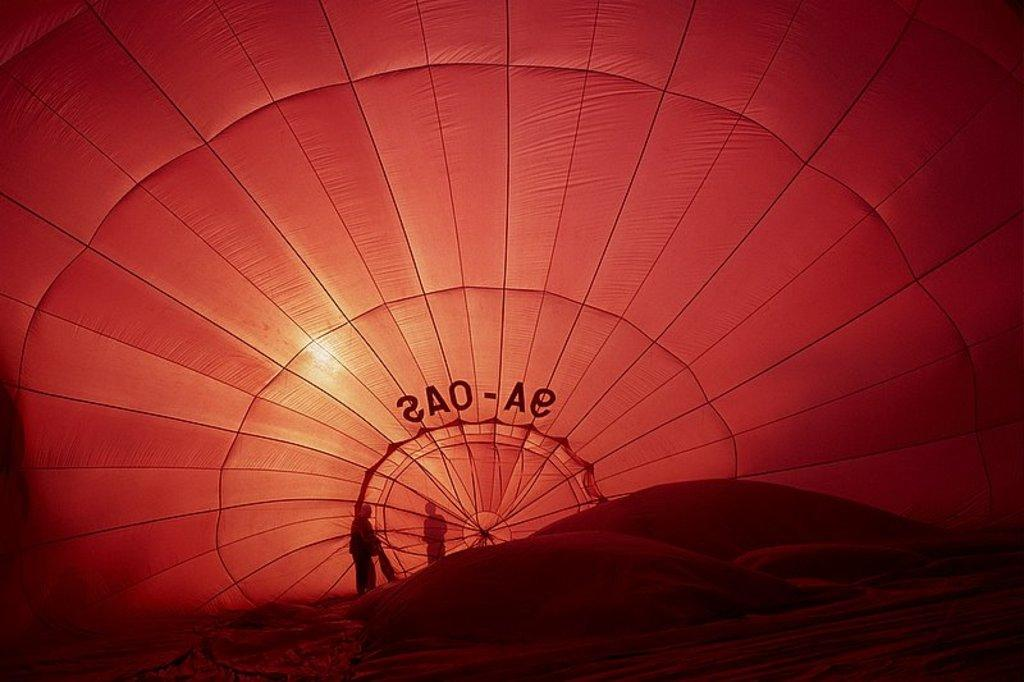How many people are in the image? There are persons in the image, but the exact number is not specified. What are the people doing in the image? The persons are standing behind an object. What color is the object they are standing behind? The object is red in color. Are there any squirrels visible in the image? There is no mention of squirrels in the provided facts, so we cannot determine if any are present in the image. 